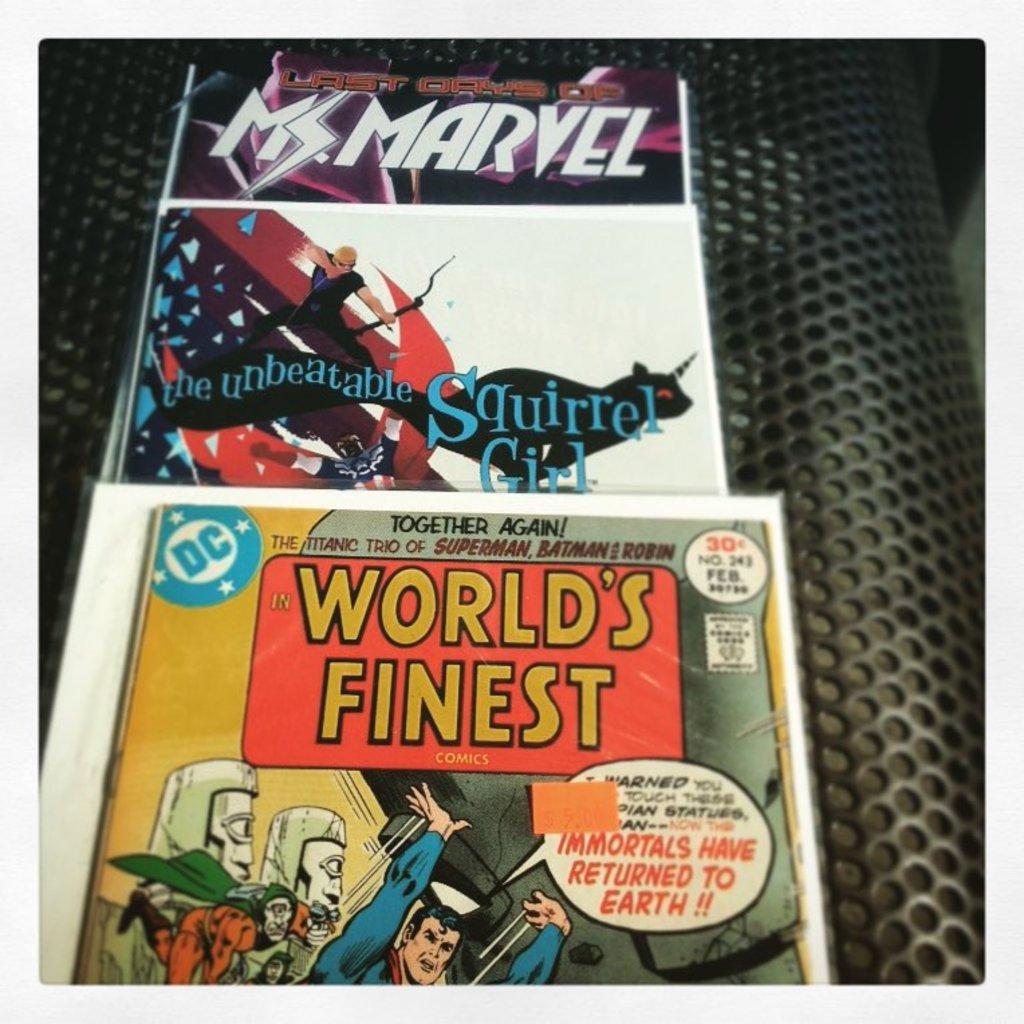What's the name of the first comic?
Keep it short and to the point. World's finest. How much did world's finest comic cost?
Give a very brief answer. 30 cents. 